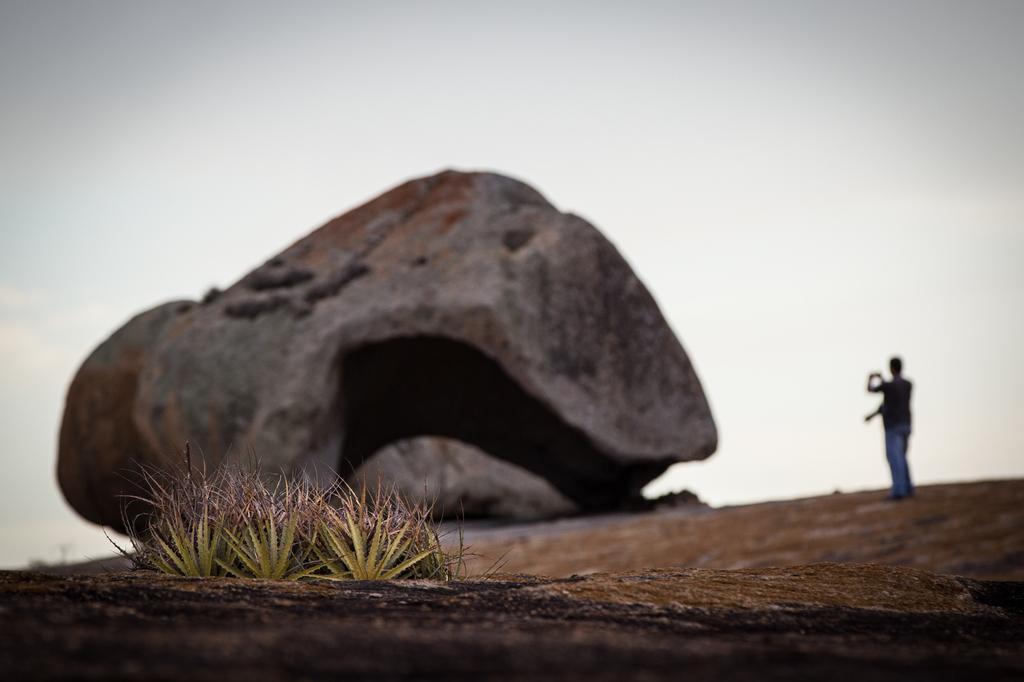In one or two sentences, can you explain what this image depicts? In this image we can see a rock. There are two persons standing and holding some object. There is a sky and few plants in the image. 